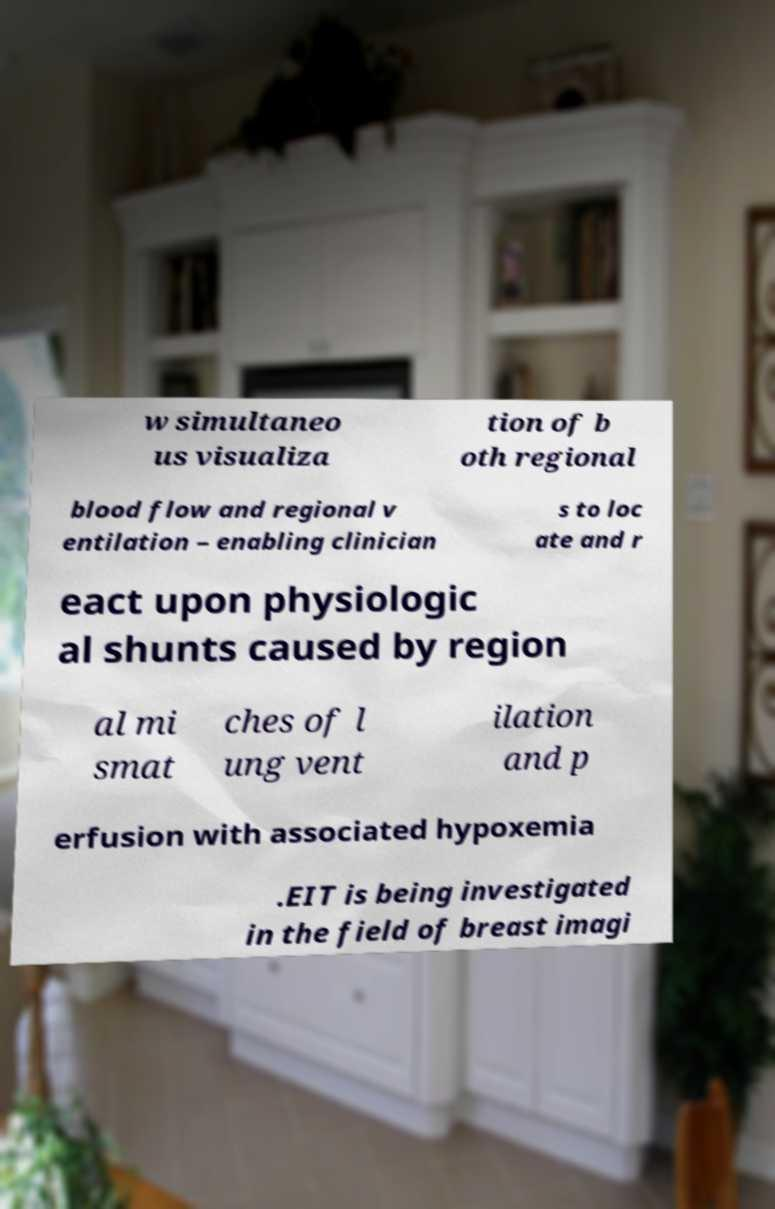Could you extract and type out the text from this image? w simultaneo us visualiza tion of b oth regional blood flow and regional v entilation – enabling clinician s to loc ate and r eact upon physiologic al shunts caused by region al mi smat ches of l ung vent ilation and p erfusion with associated hypoxemia .EIT is being investigated in the field of breast imagi 